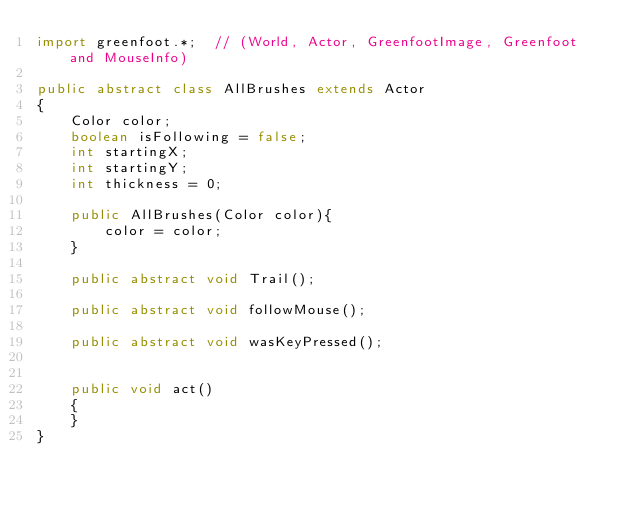Convert code to text. <code><loc_0><loc_0><loc_500><loc_500><_Java_>import greenfoot.*;  // (World, Actor, GreenfootImage, Greenfoot and MouseInfo)

public abstract class AllBrushes extends Actor
{
    Color color;
    boolean isFollowing = false;
    int startingX;
    int startingY;
    int thickness = 0;    

    public AllBrushes(Color color){
        color = color;
    }

    public abstract void Trail();

    public abstract void followMouse();                                        
       
    public abstract void wasKeyPressed();
    

    public void act() 
    {       
    }    
}
</code> 